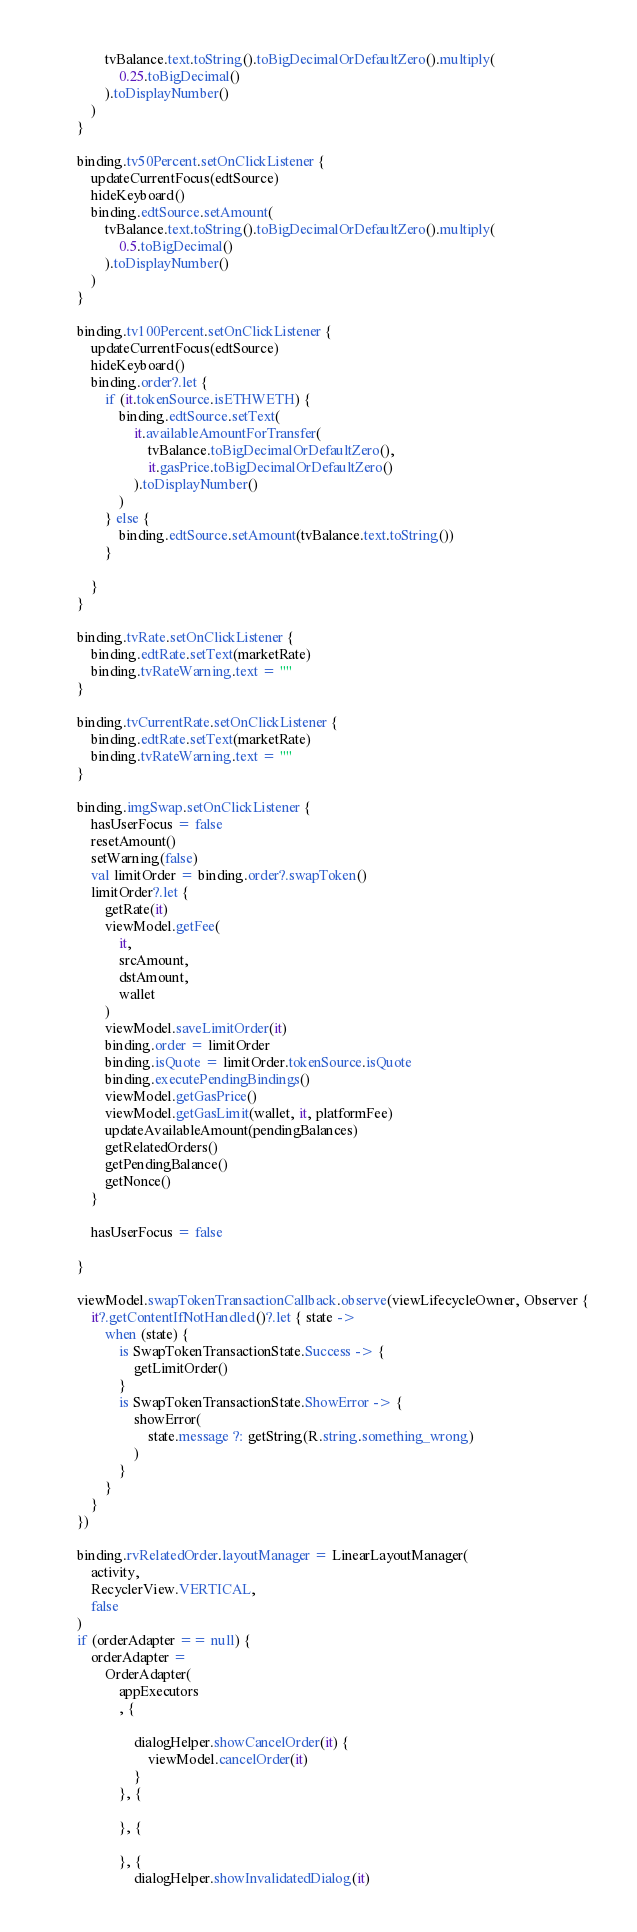Convert code to text. <code><loc_0><loc_0><loc_500><loc_500><_Kotlin_>                tvBalance.text.toString().toBigDecimalOrDefaultZero().multiply(
                    0.25.toBigDecimal()
                ).toDisplayNumber()
            )
        }

        binding.tv50Percent.setOnClickListener {
            updateCurrentFocus(edtSource)
            hideKeyboard()
            binding.edtSource.setAmount(
                tvBalance.text.toString().toBigDecimalOrDefaultZero().multiply(
                    0.5.toBigDecimal()
                ).toDisplayNumber()
            )
        }

        binding.tv100Percent.setOnClickListener {
            updateCurrentFocus(edtSource)
            hideKeyboard()
            binding.order?.let {
                if (it.tokenSource.isETHWETH) {
                    binding.edtSource.setText(
                        it.availableAmountForTransfer(
                            tvBalance.toBigDecimalOrDefaultZero(),
                            it.gasPrice.toBigDecimalOrDefaultZero()
                        ).toDisplayNumber()
                    )
                } else {
                    binding.edtSource.setAmount(tvBalance.text.toString())
                }

            }
        }

        binding.tvRate.setOnClickListener {
            binding.edtRate.setText(marketRate)
            binding.tvRateWarning.text = ""
        }

        binding.tvCurrentRate.setOnClickListener {
            binding.edtRate.setText(marketRate)
            binding.tvRateWarning.text = ""
        }

        binding.imgSwap.setOnClickListener {
            hasUserFocus = false
            resetAmount()
            setWarning(false)
            val limitOrder = binding.order?.swapToken()
            limitOrder?.let {
                getRate(it)
                viewModel.getFee(
                    it,
                    srcAmount,
                    dstAmount,
                    wallet
                )
                viewModel.saveLimitOrder(it)
                binding.order = limitOrder
                binding.isQuote = limitOrder.tokenSource.isQuote
                binding.executePendingBindings()
                viewModel.getGasPrice()
                viewModel.getGasLimit(wallet, it, platformFee)
                updateAvailableAmount(pendingBalances)
                getRelatedOrders()
                getPendingBalance()
                getNonce()
            }

            hasUserFocus = false

        }

        viewModel.swapTokenTransactionCallback.observe(viewLifecycleOwner, Observer {
            it?.getContentIfNotHandled()?.let { state ->
                when (state) {
                    is SwapTokenTransactionState.Success -> {
                        getLimitOrder()
                    }
                    is SwapTokenTransactionState.ShowError -> {
                        showError(
                            state.message ?: getString(R.string.something_wrong)
                        )
                    }
                }
            }
        })

        binding.rvRelatedOrder.layoutManager = LinearLayoutManager(
            activity,
            RecyclerView.VERTICAL,
            false
        )
        if (orderAdapter == null) {
            orderAdapter =
                OrderAdapter(
                    appExecutors
                    , {

                        dialogHelper.showCancelOrder(it) {
                            viewModel.cancelOrder(it)
                        }
                    }, {

                    }, {

                    }, {
                        dialogHelper.showInvalidatedDialog(it)</code> 